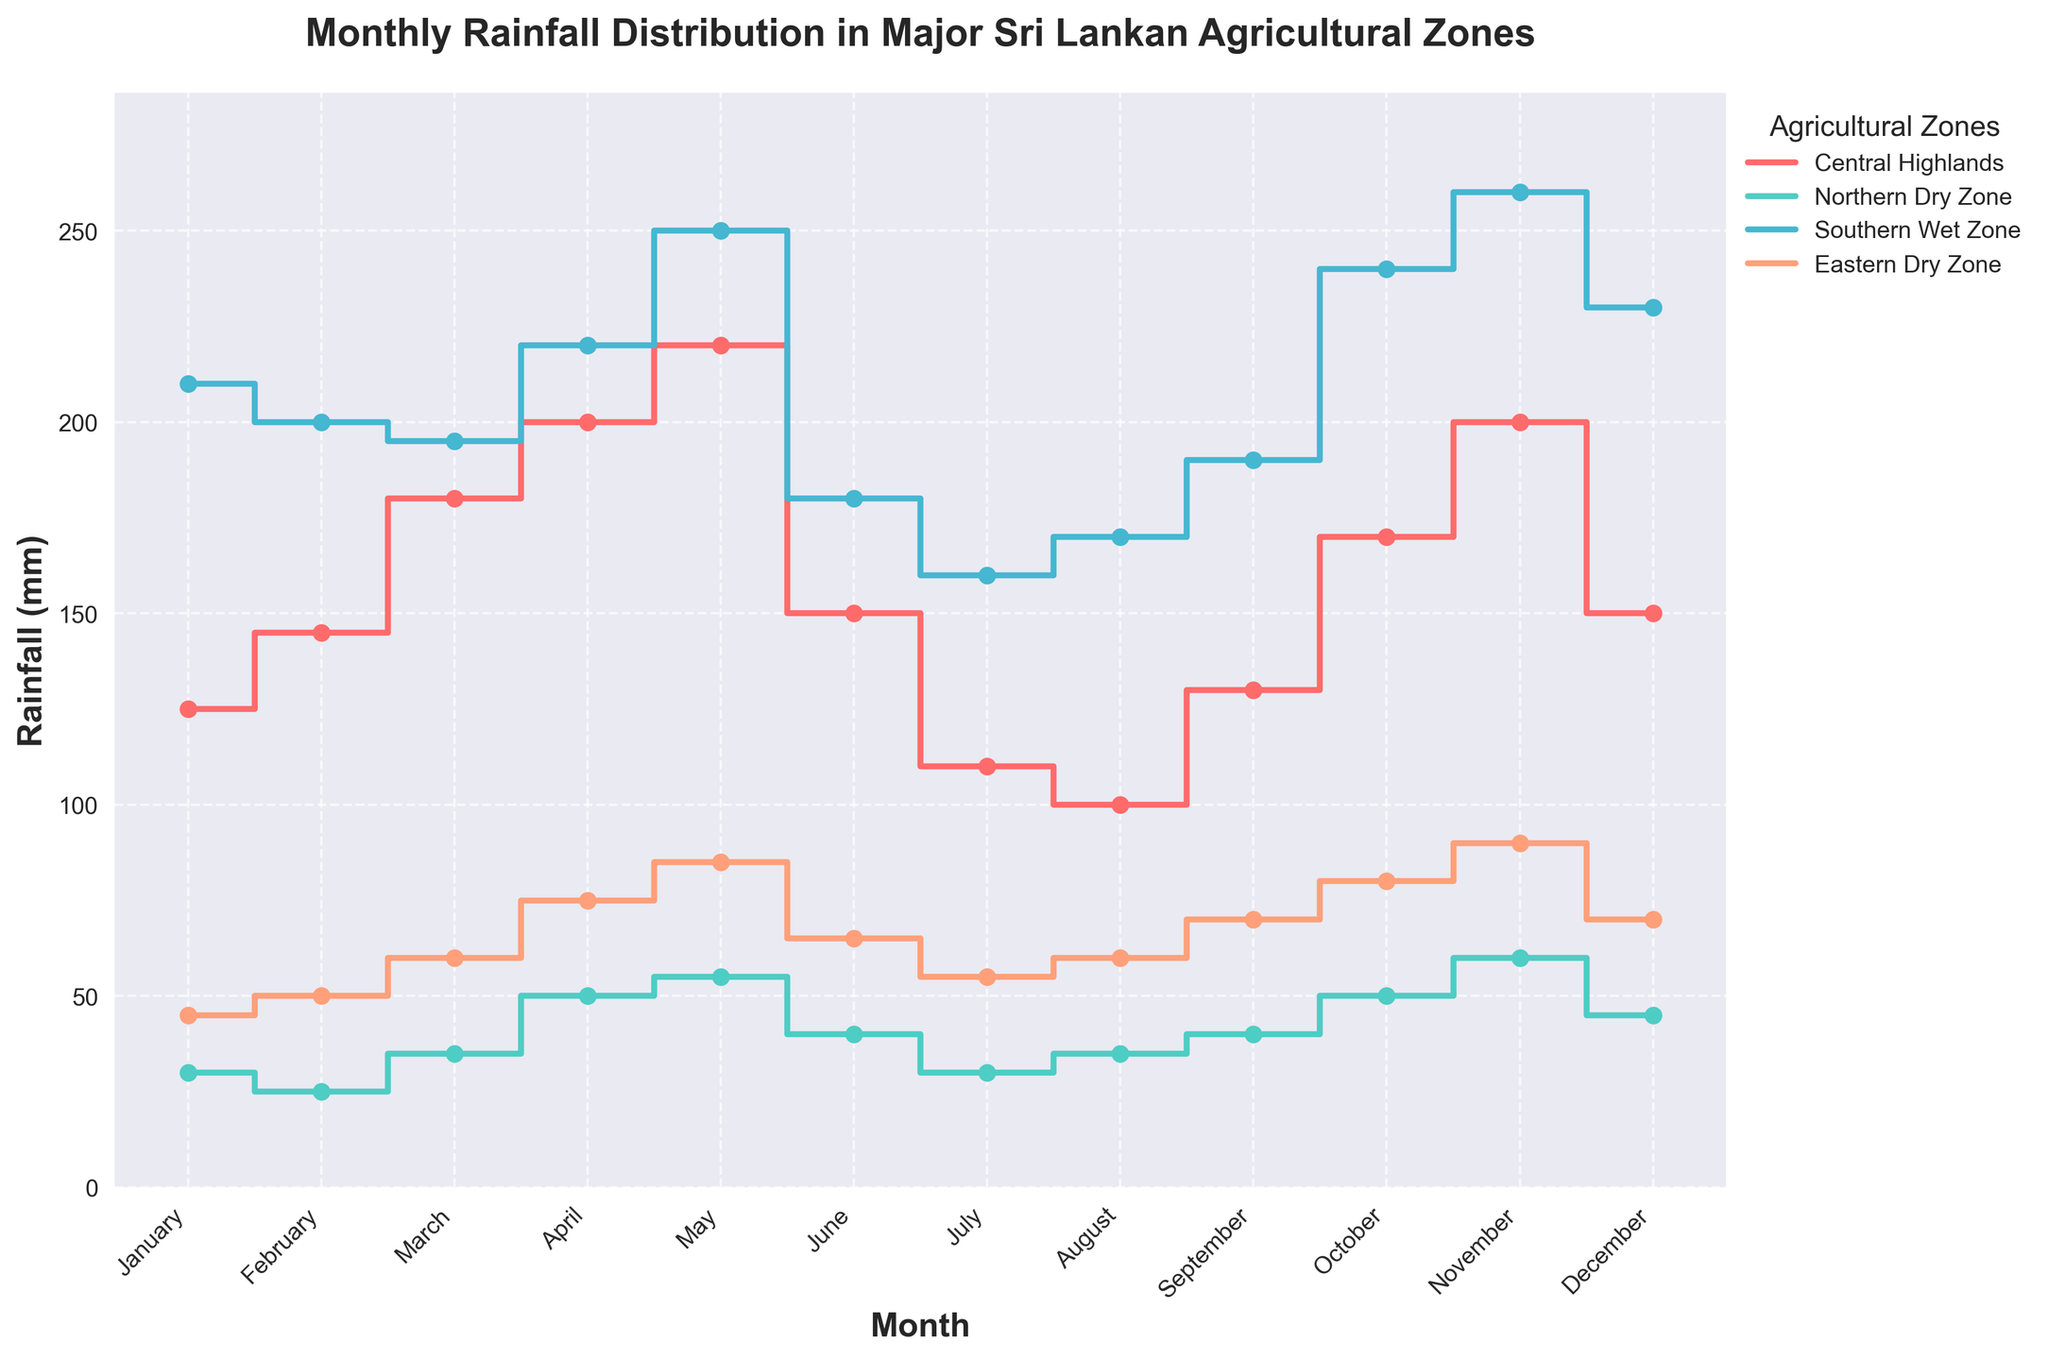What is the title of the figure? The title is usually placed at the top of the figure. Referring to the figure, the title is prominently displayed.
Answer: Monthly Rainfall Distribution in Major Sri Lankan Agricultural Zones Which region had the highest rainfall in November? Looking at the plotted data points for November, we find the region with the highest value on the y-axis. The Southern Wet Zone had the highest rainfall.
Answer: Southern Wet Zone What is the general pattern of rainfall in the Central Highlands from January to June? Examining the line for the Central Highlands from January to June, we see that the rainfall generally increases until May, then decreases in June.
Answer: Increases until May, then decreases How does the rainfall in the Northern Dry Zone compare between January and June? By comparing the data points for January and June in the Northern Dry Zone, we observe that rainfall starts at 30 mm in January and increases to 40 mm in June.
Answer: Increases Which month shows the highest rainfall for the Eastern Dry Zone? We identify the highest point along the plot for the Eastern Dry Zone, which corresponds to November.
Answer: November On average, which region has the most consistent rainfall throughout the year? By examining the variation in the stair plots for each region, the Northern Dry Zone shows the least fluctuation over the months.
Answer: Northern Dry Zone What is the difference in rainfall between the Southern Wet Zone and the Central Highlands in April? The figure shows that in April, the Southern Wet Zone has 220 mm, and the Central Highlands has 200 mm. The difference is 220 - 200.
Answer: 20 mm In which months does the Eastern Dry Zone experience an increase in rainfall compared to the previous month? From the plot, if the slope is upward, it indicates an increase. This happens in March, April, May, September, October, and November.
Answer: March, April, May, September, October, November What trend can be observed in the Southern Wet Zone from August to November? Referring to the dataset, we see a steady increase in rainfall from August to a peak in November.
Answer: Increasing trend How does the rainfall in July for the Northern Dry Zone compare to August for the same region? The figure shows that the rainfall in July and August for the Northern Dry Zone are 30 mm and 35 mm, respectively. So, the rainfall in August is greater.
Answer: Greater in August 